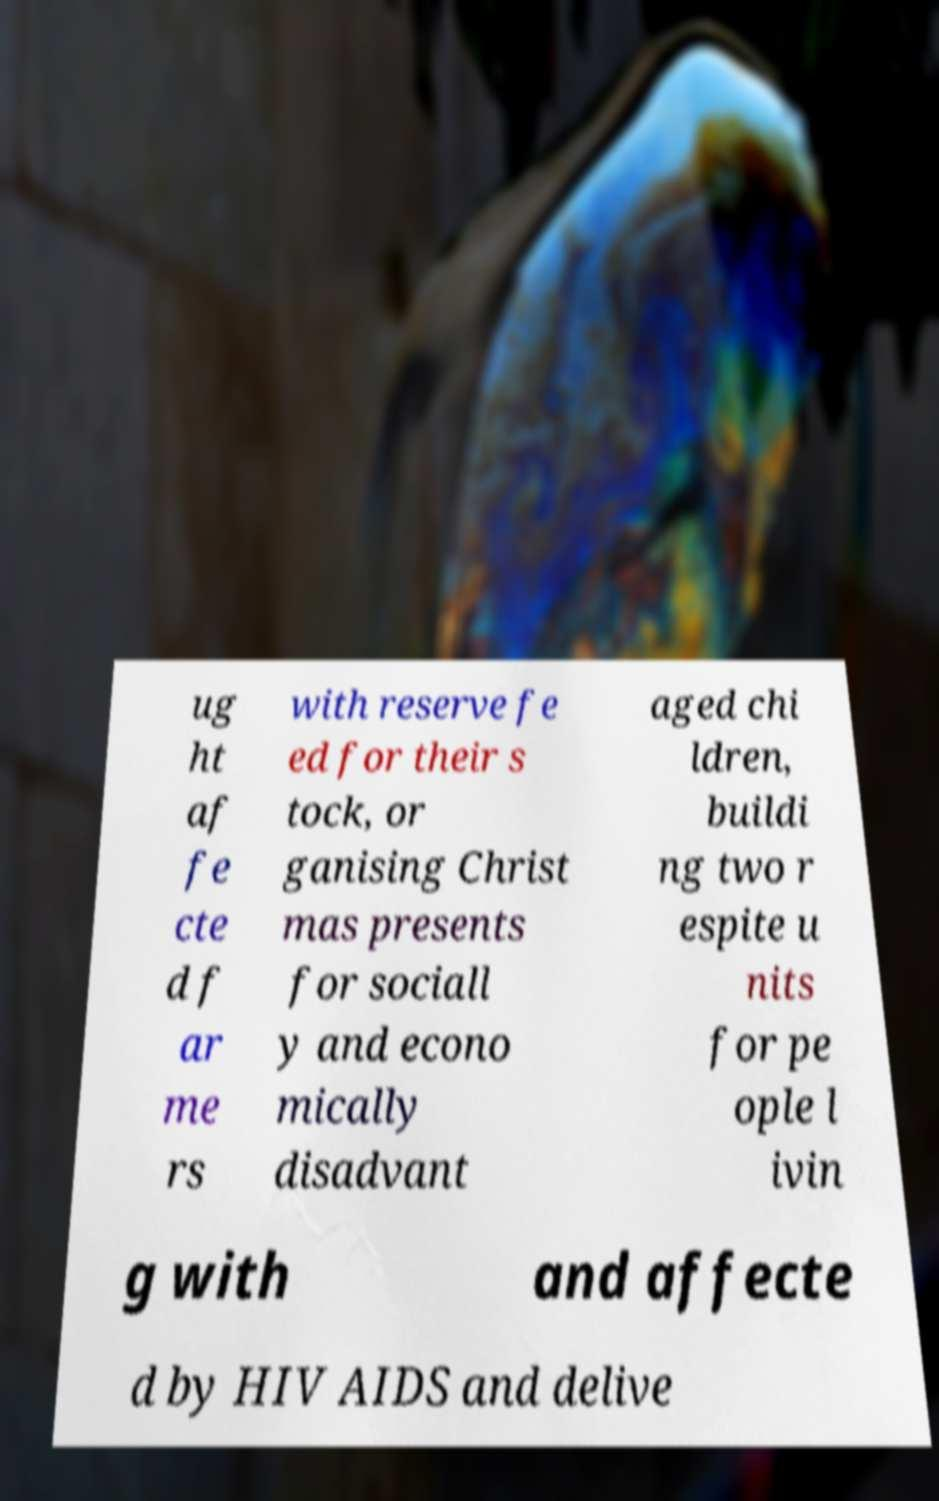Can you accurately transcribe the text from the provided image for me? ug ht af fe cte d f ar me rs with reserve fe ed for their s tock, or ganising Christ mas presents for sociall y and econo mically disadvant aged chi ldren, buildi ng two r espite u nits for pe ople l ivin g with and affecte d by HIV AIDS and delive 